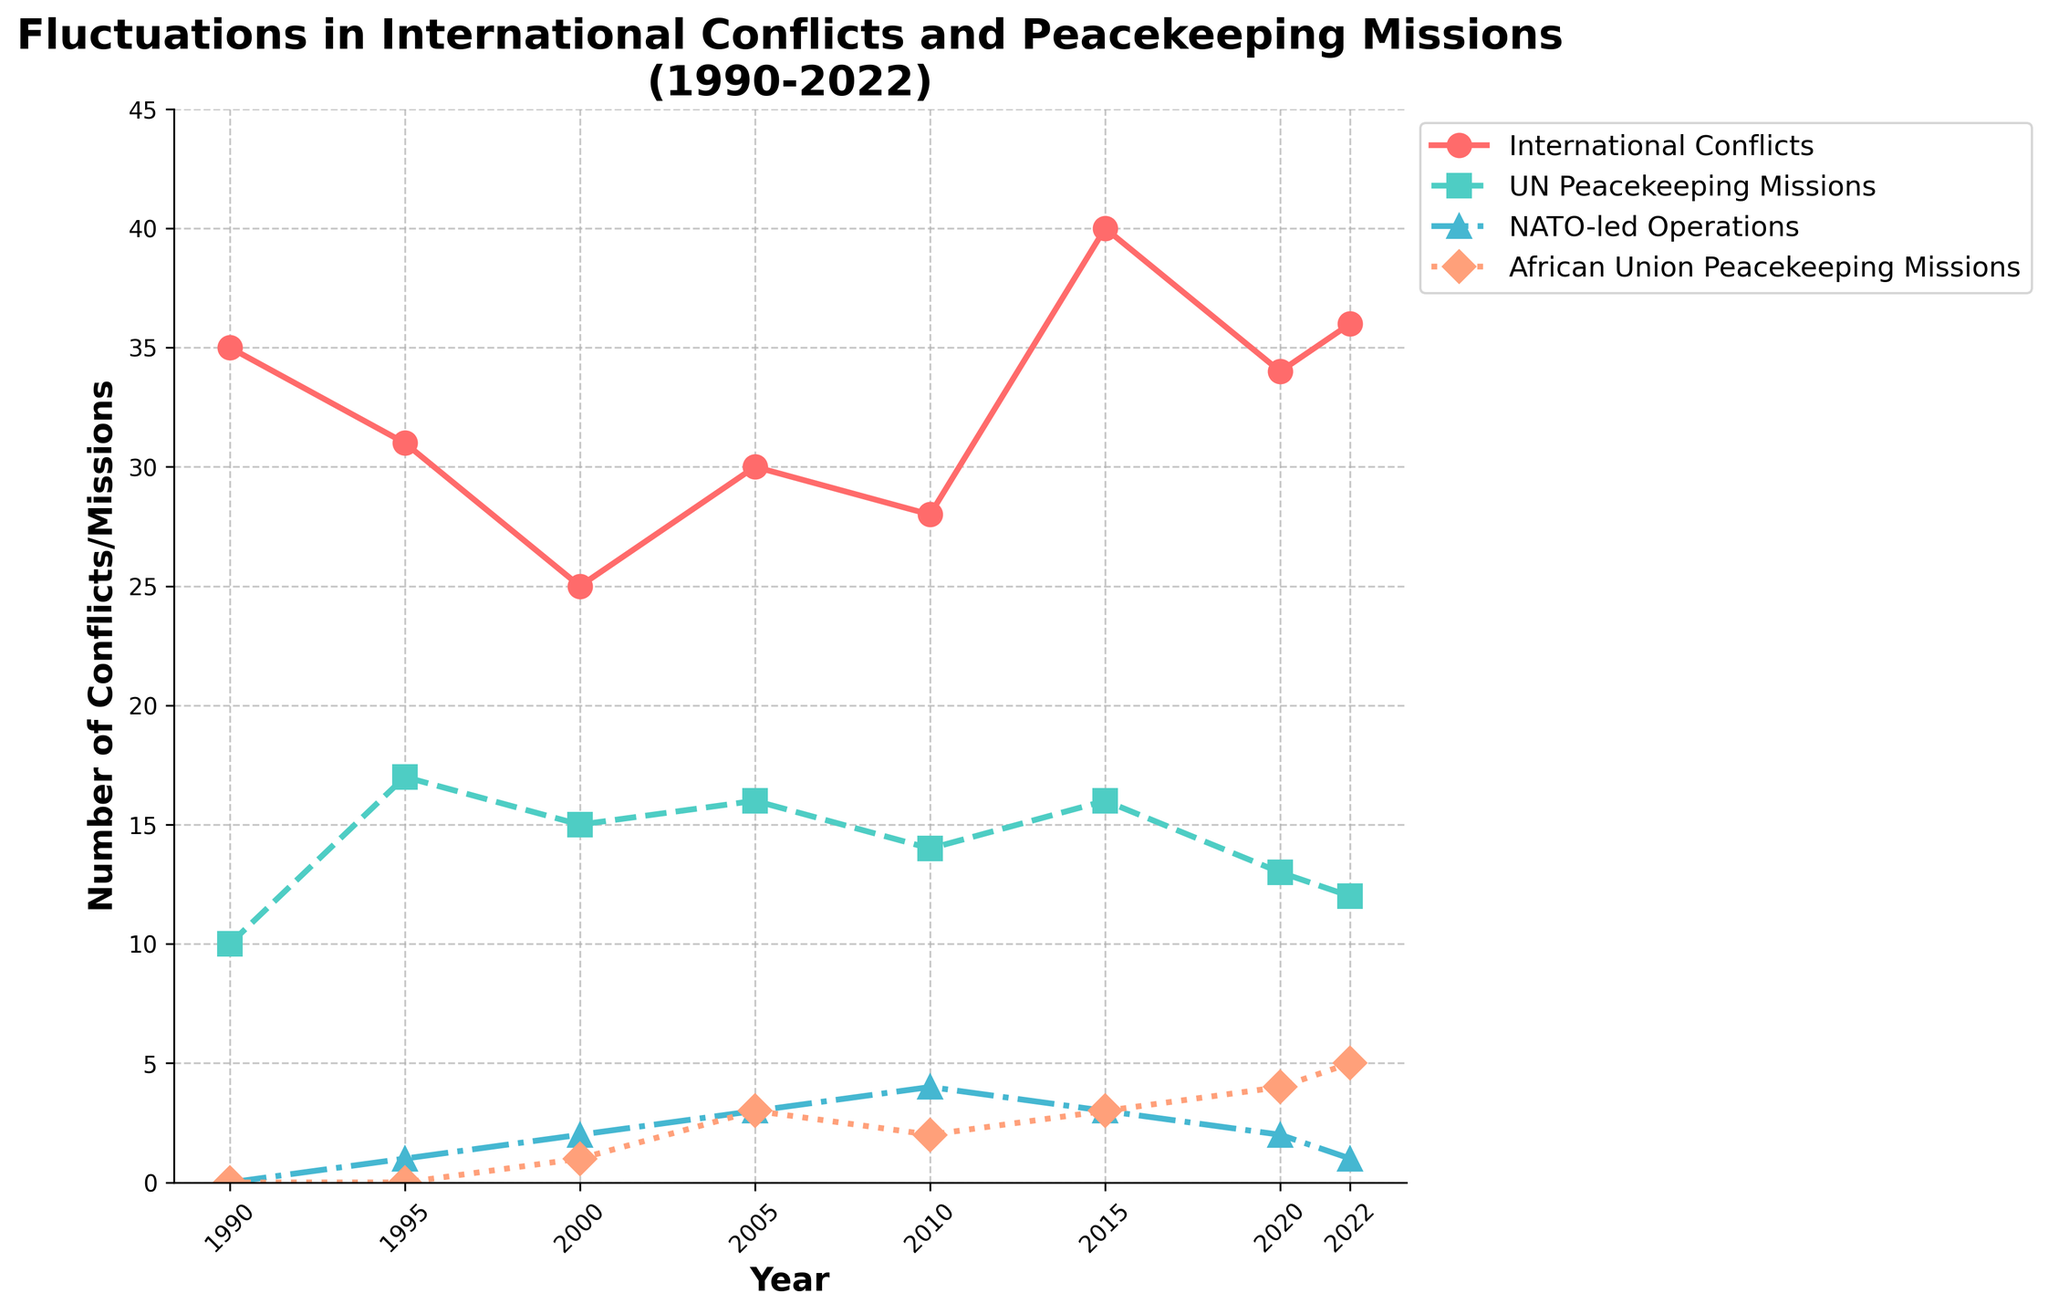Which year had the highest number of international conflicts? To find the year with the highest number of international conflicts, look at the line labeled "International Conflicts" and determine its peak value on the timeline. The highest number of international conflicts is in 2015.
Answer: 2015 Between 2010 and 2022, how did the number of UN Peacekeeping Missions change? Check the values for "UN Peacekeeping Missions" for the years 2010 and 2022. In 2010, there were 14 missions, and in 2022, there were 12. The number of UN Peacekeeping Missions decreased by 2.
Answer: decreased by 2 What is the trend in NATO-led Operations from 1990 to 2022? Evaluate the number of "NATO-led Operations" across the timeline. The line starts at 0 in 1990, increases to a peak of 4 in 2010, and then declines to 1 by 2022. The general trend is an increase until 2010, followed by a decrease.
Answer: increase then decrease Which organization had the highest increase in peacekeeping missions from 2000 to 2022? Compare the changes in peacekeeping missions of UN, NATO, and African Union from 2000 to 2022. The UN decreases from 15 to 12, NATO remains almost the same (increasing from 2 to 1), and African Union increases from 1 to 5. Thus, the African Union had the highest increase.
Answer: African Union In which years were there exactly 16 peacekeeping missions conducted by the UN? Identify the years where the "UN Peacekeeping Missions" line hits 16. These years are 2005 and 2015.
Answer: 2005 and 2015 What is the difference between the number of international conflicts and UN Peacekeeping Missions in 2022? Look at the values for "International Conflicts" and "UN Peacekeeping Missions" in 2022. The number of conflicts is 36, and the missions are 12. The difference is 36 - 12 = 24.
Answer: 24 How many times did the number of African Union Peacekeeping Missions exceed those of NATO-led Operations? Compare the "African Union Peacekeeping Missions" and "NATO-led Operations" lines across the timeline. The African Union missions exceed NATO operations in 2020 and 2022, which makes it twice.
Answer: 2 times 